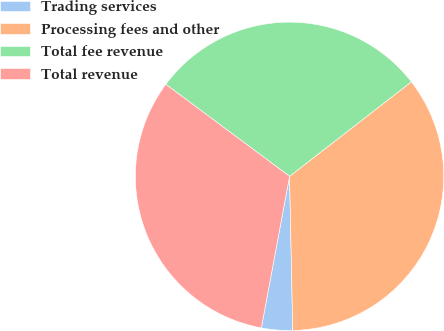Convert chart to OTSL. <chart><loc_0><loc_0><loc_500><loc_500><pie_chart><fcel>Trading services<fcel>Processing fees and other<fcel>Total fee revenue<fcel>Total revenue<nl><fcel>3.26%<fcel>35.18%<fcel>29.32%<fcel>32.25%<nl></chart> 